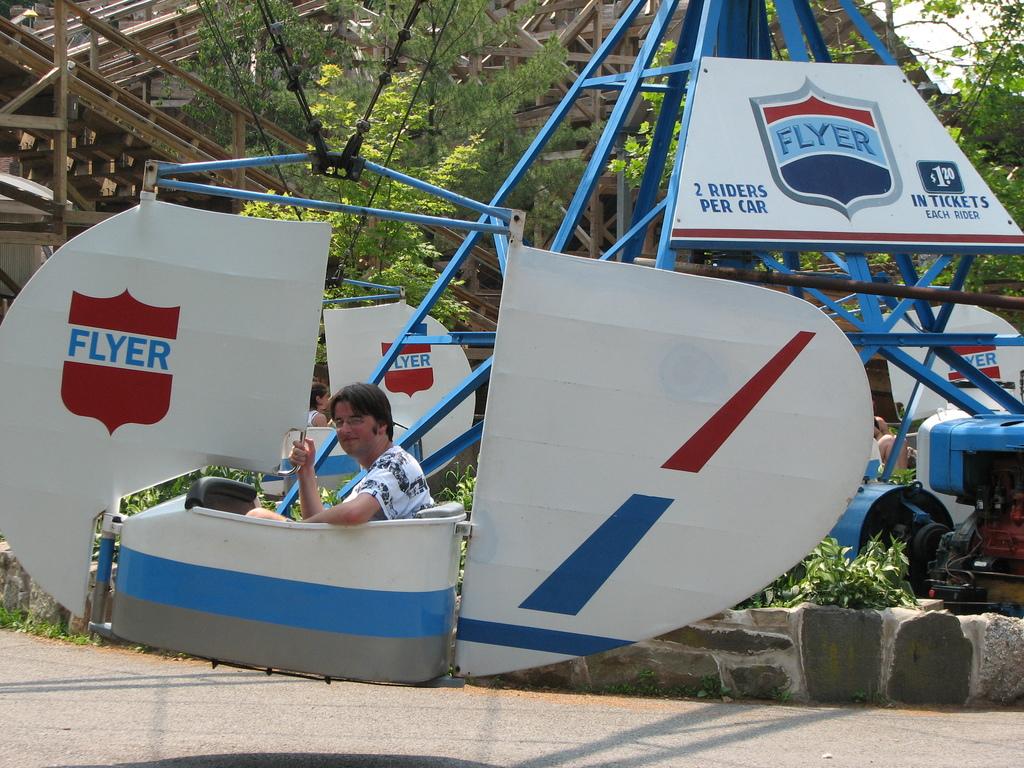How many riders are allowed per car?
Provide a succinct answer. 2. What is the brand name of this ride?
Offer a very short reply. Flyer. 